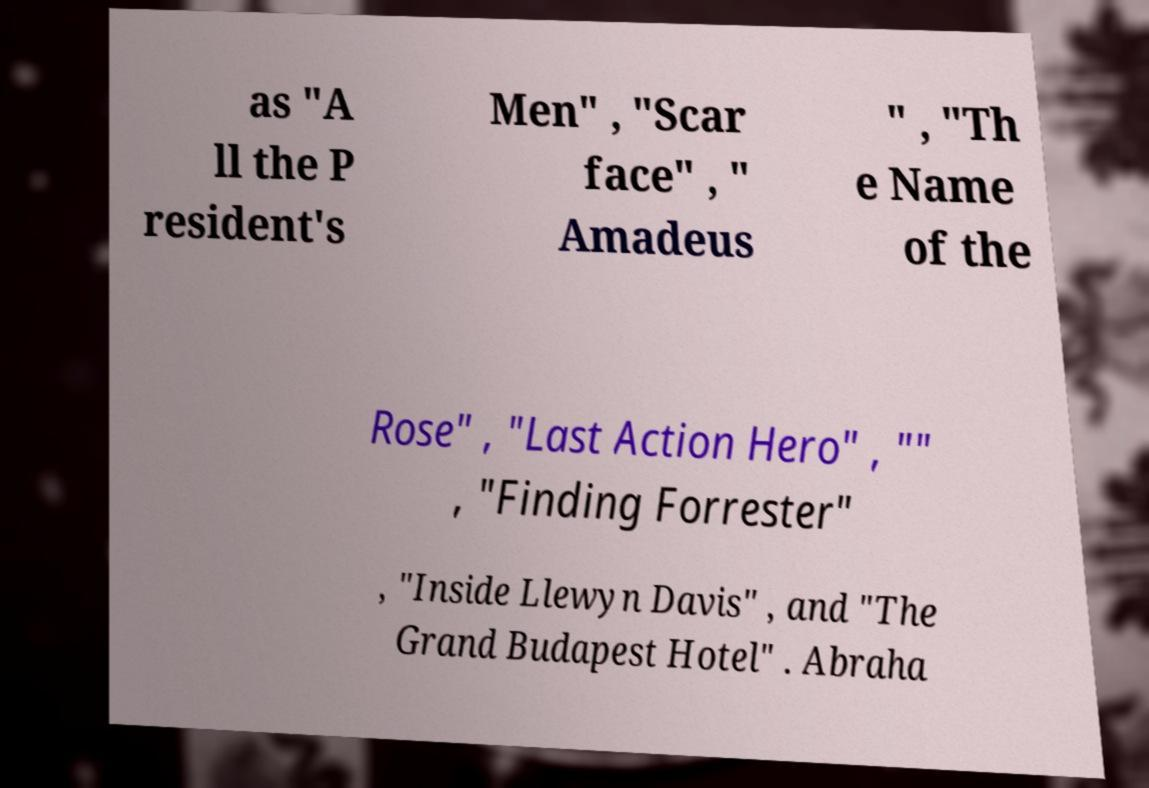Could you assist in decoding the text presented in this image and type it out clearly? as "A ll the P resident's Men" , "Scar face" , " Amadeus " , "Th e Name of the Rose" , "Last Action Hero" , "" , "Finding Forrester" , "Inside Llewyn Davis" , and "The Grand Budapest Hotel" . Abraha 